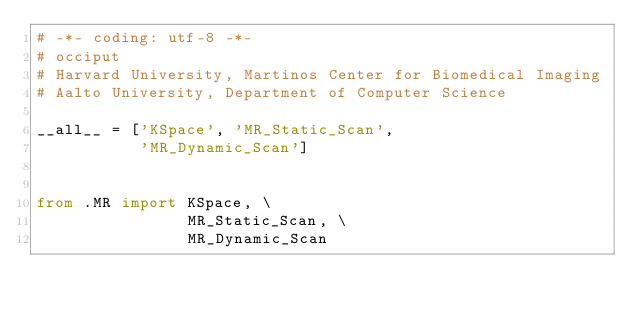Convert code to text. <code><loc_0><loc_0><loc_500><loc_500><_Python_># -*- coding: utf-8 -*-
# occiput
# Harvard University, Martinos Center for Biomedical Imaging
# Aalto University, Department of Computer Science

__all__ = ['KSpace', 'MR_Static_Scan',
           'MR_Dynamic_Scan']


from .MR import KSpace, \
                MR_Static_Scan, \
                MR_Dynamic_Scan</code> 